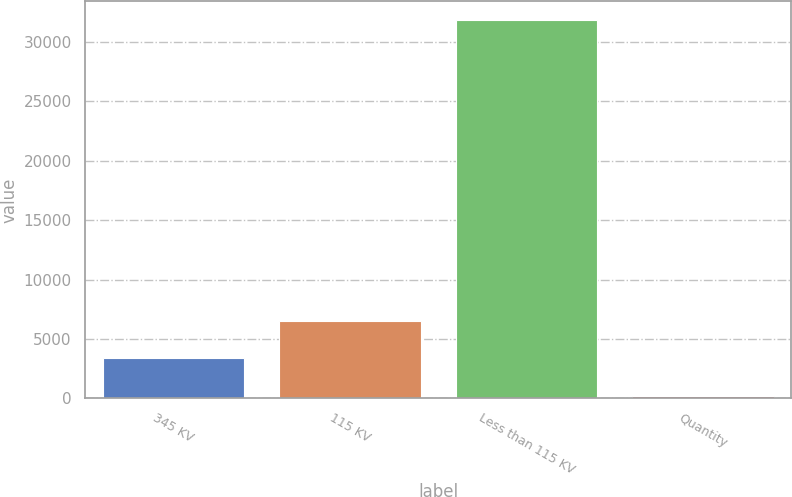Convert chart to OTSL. <chart><loc_0><loc_0><loc_500><loc_500><bar_chart><fcel>345 KV<fcel>115 KV<fcel>Less than 115 KV<fcel>Quantity<nl><fcel>3363.4<fcel>6523.8<fcel>31807<fcel>203<nl></chart> 